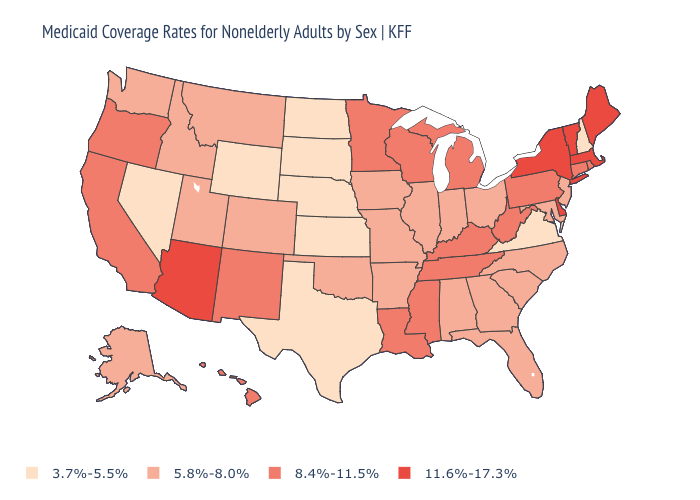Does Indiana have a lower value than Colorado?
Be succinct. No. What is the lowest value in the USA?
Short answer required. 3.7%-5.5%. Name the states that have a value in the range 3.7%-5.5%?
Write a very short answer. Kansas, Nebraska, Nevada, New Hampshire, North Dakota, South Dakota, Texas, Virginia, Wyoming. What is the value of Idaho?
Quick response, please. 5.8%-8.0%. Name the states that have a value in the range 3.7%-5.5%?
Answer briefly. Kansas, Nebraska, Nevada, New Hampshire, North Dakota, South Dakota, Texas, Virginia, Wyoming. What is the value of California?
Be succinct. 8.4%-11.5%. What is the lowest value in the USA?
Be succinct. 3.7%-5.5%. Name the states that have a value in the range 8.4%-11.5%?
Write a very short answer. California, Connecticut, Hawaii, Kentucky, Louisiana, Michigan, Minnesota, Mississippi, New Mexico, Oregon, Pennsylvania, Rhode Island, Tennessee, West Virginia, Wisconsin. Among the states that border Oklahoma , does Colorado have the lowest value?
Write a very short answer. No. What is the value of Montana?
Keep it brief. 5.8%-8.0%. What is the value of Oklahoma?
Write a very short answer. 5.8%-8.0%. What is the value of Utah?
Write a very short answer. 5.8%-8.0%. Name the states that have a value in the range 3.7%-5.5%?
Answer briefly. Kansas, Nebraska, Nevada, New Hampshire, North Dakota, South Dakota, Texas, Virginia, Wyoming. Name the states that have a value in the range 5.8%-8.0%?
Give a very brief answer. Alabama, Alaska, Arkansas, Colorado, Florida, Georgia, Idaho, Illinois, Indiana, Iowa, Maryland, Missouri, Montana, New Jersey, North Carolina, Ohio, Oklahoma, South Carolina, Utah, Washington. Which states have the lowest value in the West?
Keep it brief. Nevada, Wyoming. 